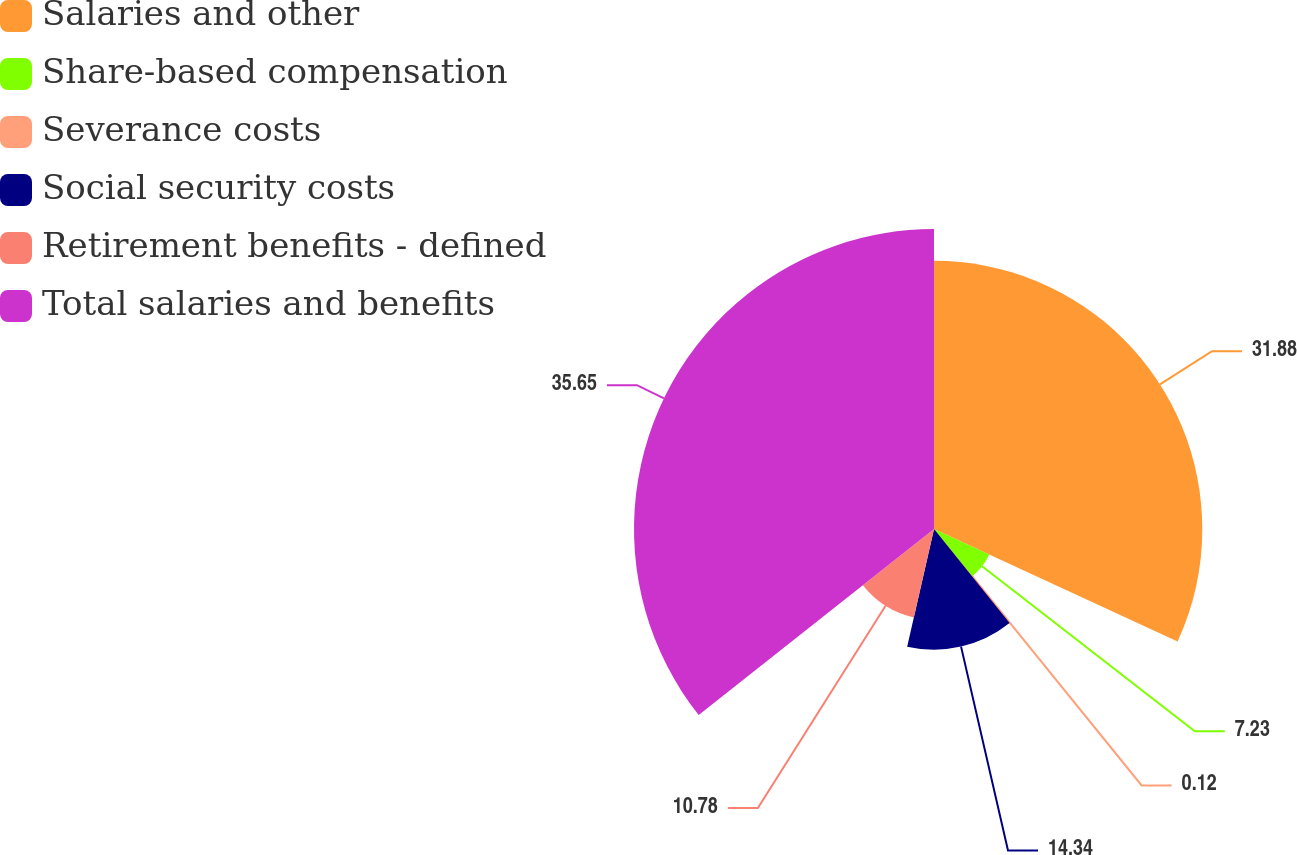<chart> <loc_0><loc_0><loc_500><loc_500><pie_chart><fcel>Salaries and other<fcel>Share-based compensation<fcel>Severance costs<fcel>Social security costs<fcel>Retirement benefits - defined<fcel>Total salaries and benefits<nl><fcel>31.88%<fcel>7.23%<fcel>0.12%<fcel>14.34%<fcel>10.78%<fcel>35.65%<nl></chart> 